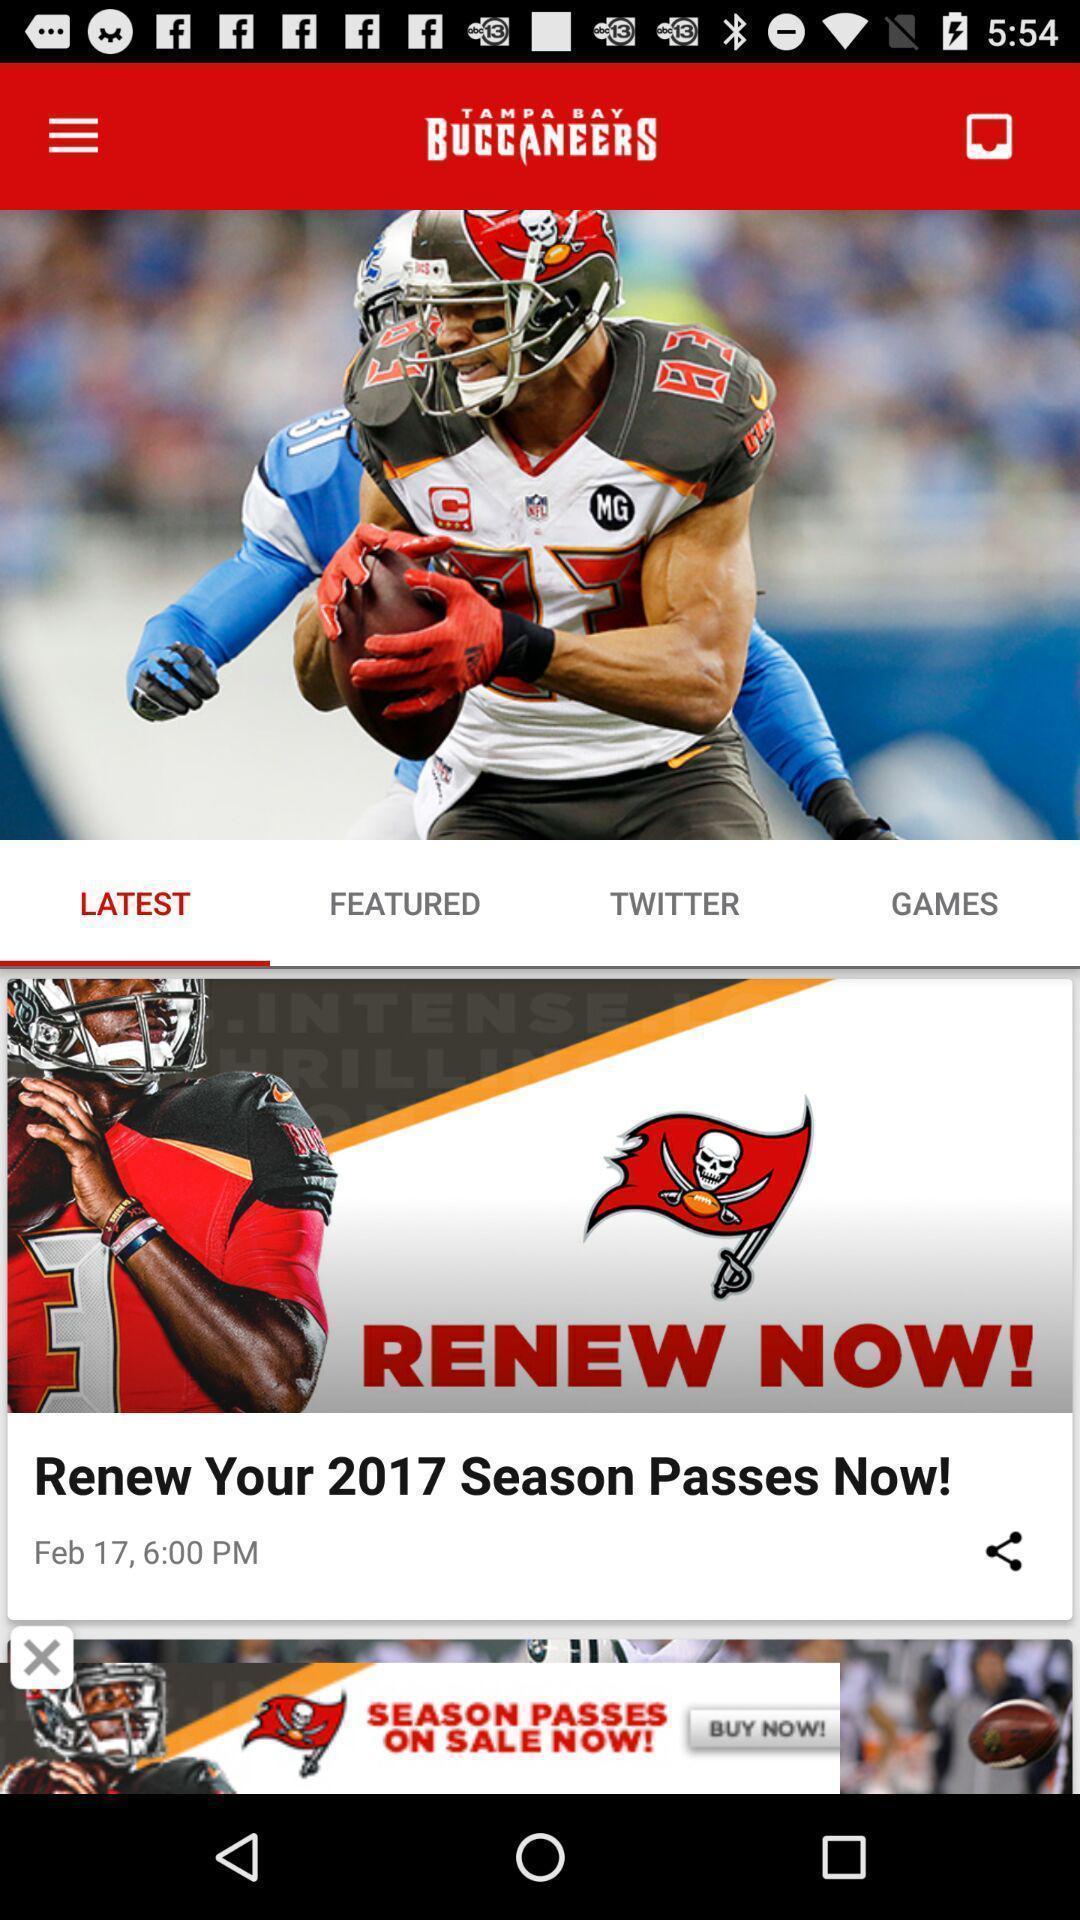Provide a detailed account of this screenshot. Page of a sports app with various options. 